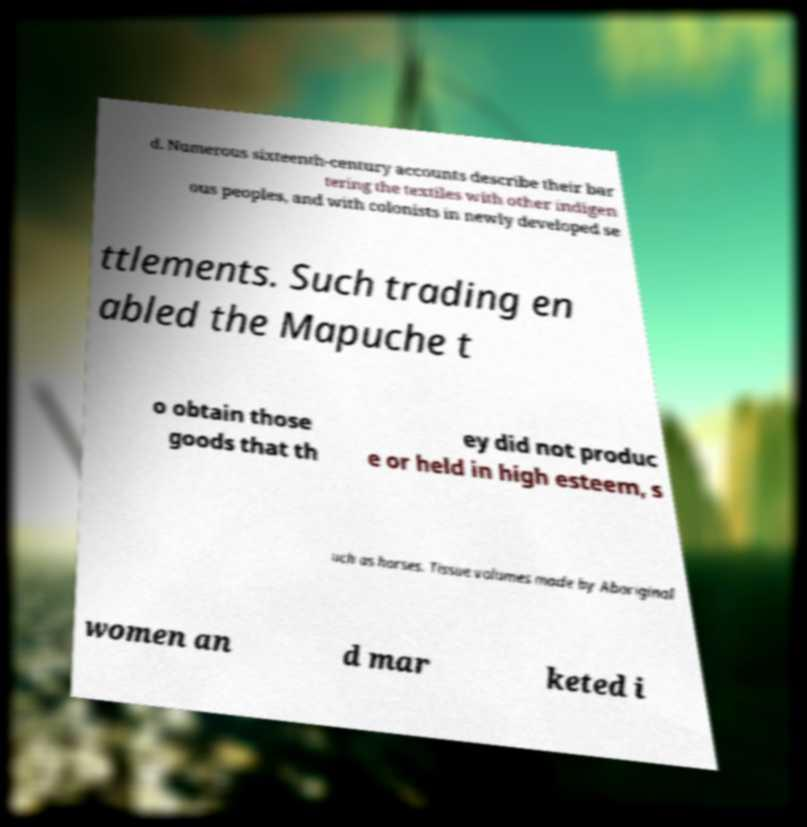Please identify and transcribe the text found in this image. d. Numerous sixteenth-century accounts describe their bar tering the textiles with other indigen ous peoples, and with colonists in newly developed se ttlements. Such trading en abled the Mapuche t o obtain those goods that th ey did not produc e or held in high esteem, s uch as horses. Tissue volumes made by Aboriginal women an d mar keted i 